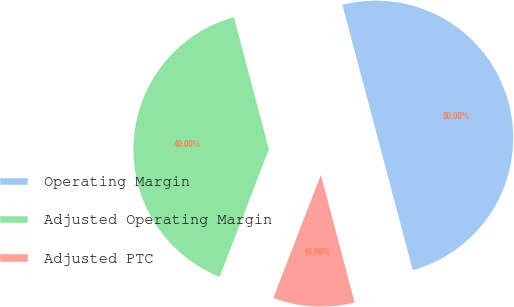<chart> <loc_0><loc_0><loc_500><loc_500><pie_chart><fcel>Operating Margin<fcel>Adjusted Operating Margin<fcel>Adjusted PTC<nl><fcel>50.0%<fcel>40.0%<fcel>10.0%<nl></chart> 